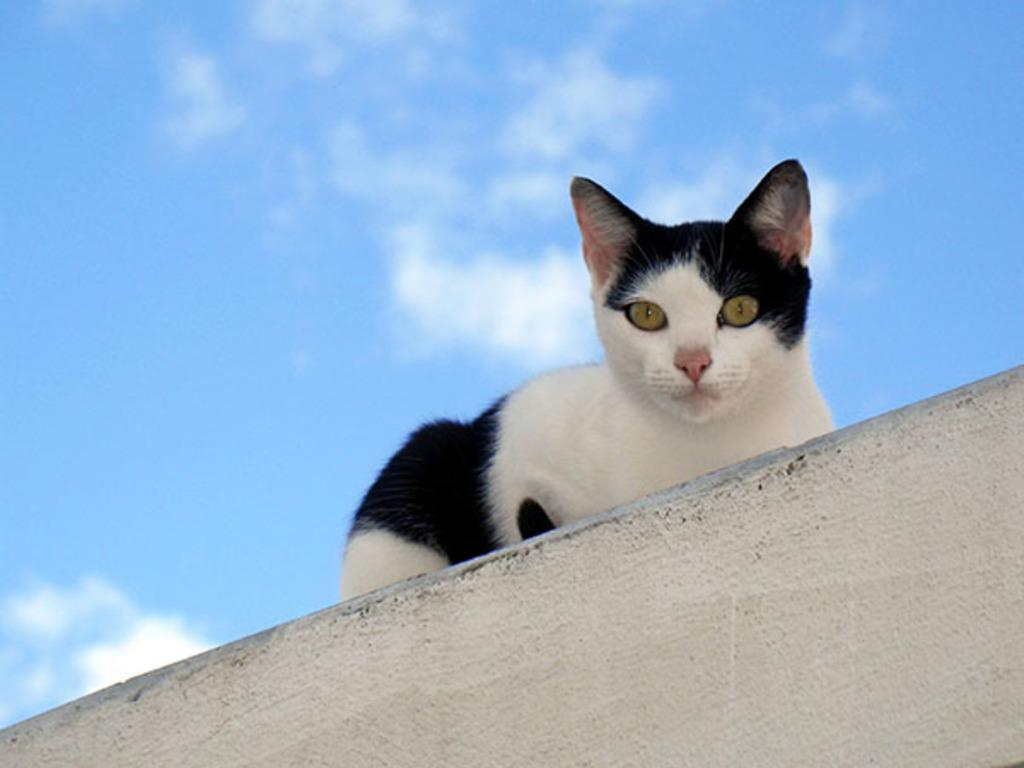What animal is present in the image? There is a cat in the image. Where is the cat located? The cat is on a wall. What can be seen in the background of the image? There is a sky visible in the background of the image. What is the condition of the sky in the image? There are clouds in the sky. Can you see the cat giving a kiss to its friend in the image? There is no friend or kiss present in the image; it only features a cat on a wall with a sky in the background. 